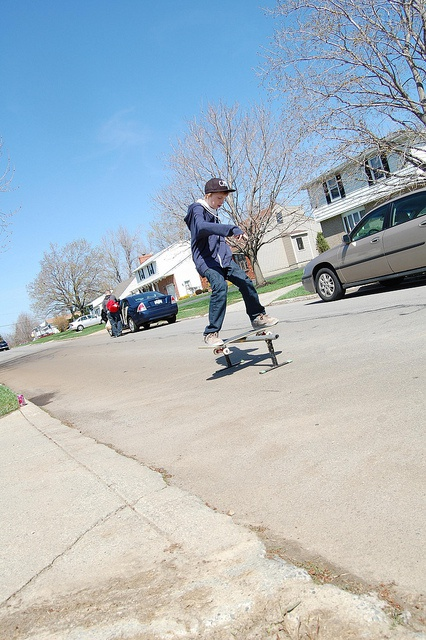Describe the objects in this image and their specific colors. I can see car in gray, black, darkgray, and darkblue tones, people in gray, black, and navy tones, car in gray, black, navy, and blue tones, skateboard in gray, darkgray, and lightgray tones, and people in gray, black, and darkgray tones in this image. 